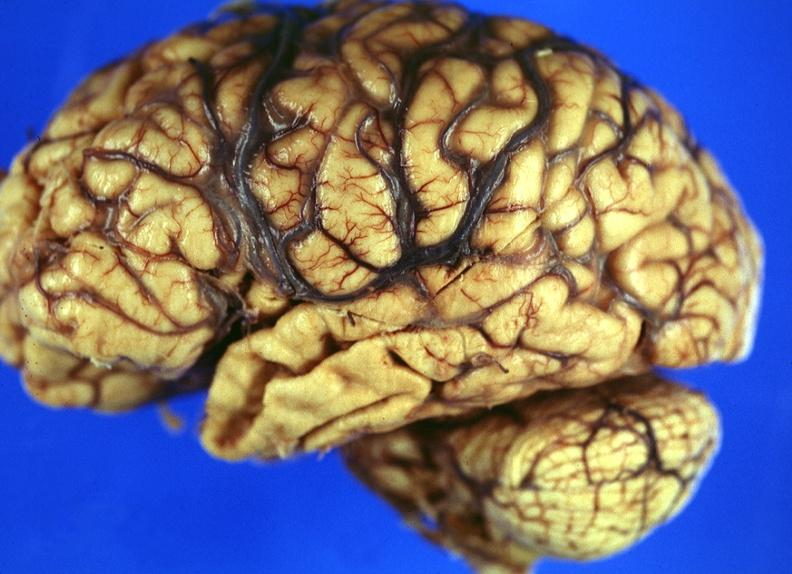what does this image show?
Answer the question using a single word or phrase. Brain 